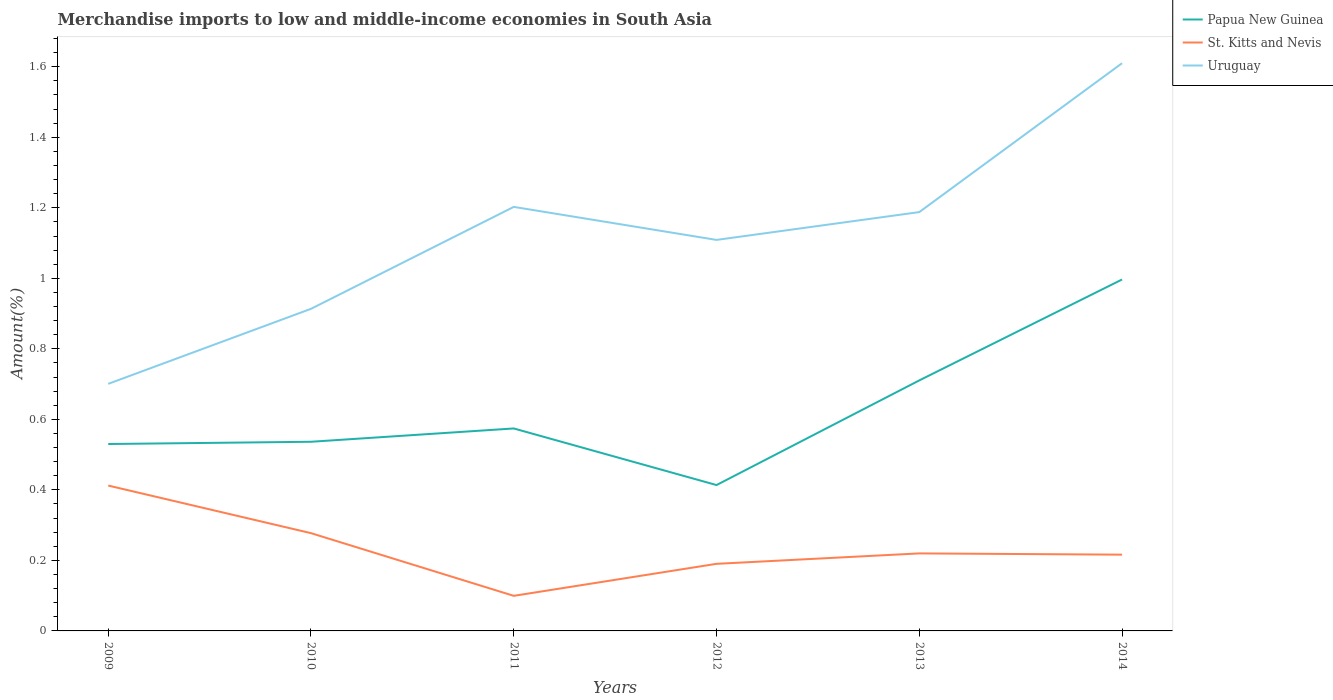Does the line corresponding to Uruguay intersect with the line corresponding to Papua New Guinea?
Offer a very short reply. No. Is the number of lines equal to the number of legend labels?
Offer a very short reply. Yes. Across all years, what is the maximum percentage of amount earned from merchandise imports in Papua New Guinea?
Offer a terse response. 0.41. What is the total percentage of amount earned from merchandise imports in Uruguay in the graph?
Offer a terse response. -0.42. What is the difference between the highest and the second highest percentage of amount earned from merchandise imports in St. Kitts and Nevis?
Your response must be concise. 0.31. How many lines are there?
Keep it short and to the point. 3. How many years are there in the graph?
Make the answer very short. 6. Does the graph contain any zero values?
Offer a very short reply. No. Does the graph contain grids?
Give a very brief answer. No. What is the title of the graph?
Give a very brief answer. Merchandise imports to low and middle-income economies in South Asia. Does "St. Martin (French part)" appear as one of the legend labels in the graph?
Ensure brevity in your answer.  No. What is the label or title of the X-axis?
Ensure brevity in your answer.  Years. What is the label or title of the Y-axis?
Your answer should be very brief. Amount(%). What is the Amount(%) in Papua New Guinea in 2009?
Make the answer very short. 0.53. What is the Amount(%) of St. Kitts and Nevis in 2009?
Provide a short and direct response. 0.41. What is the Amount(%) in Uruguay in 2009?
Offer a terse response. 0.7. What is the Amount(%) in Papua New Guinea in 2010?
Your answer should be compact. 0.54. What is the Amount(%) of St. Kitts and Nevis in 2010?
Make the answer very short. 0.28. What is the Amount(%) in Uruguay in 2010?
Your answer should be compact. 0.91. What is the Amount(%) in Papua New Guinea in 2011?
Offer a very short reply. 0.57. What is the Amount(%) of St. Kitts and Nevis in 2011?
Your response must be concise. 0.1. What is the Amount(%) of Uruguay in 2011?
Provide a short and direct response. 1.2. What is the Amount(%) of Papua New Guinea in 2012?
Provide a succinct answer. 0.41. What is the Amount(%) of St. Kitts and Nevis in 2012?
Provide a succinct answer. 0.19. What is the Amount(%) of Uruguay in 2012?
Keep it short and to the point. 1.11. What is the Amount(%) in Papua New Guinea in 2013?
Your answer should be compact. 0.71. What is the Amount(%) in St. Kitts and Nevis in 2013?
Your answer should be very brief. 0.22. What is the Amount(%) of Uruguay in 2013?
Your answer should be very brief. 1.19. What is the Amount(%) of Papua New Guinea in 2014?
Your response must be concise. 1. What is the Amount(%) in St. Kitts and Nevis in 2014?
Keep it short and to the point. 0.22. What is the Amount(%) in Uruguay in 2014?
Keep it short and to the point. 1.61. Across all years, what is the maximum Amount(%) in Papua New Guinea?
Offer a very short reply. 1. Across all years, what is the maximum Amount(%) in St. Kitts and Nevis?
Offer a very short reply. 0.41. Across all years, what is the maximum Amount(%) in Uruguay?
Offer a very short reply. 1.61. Across all years, what is the minimum Amount(%) of Papua New Guinea?
Your answer should be compact. 0.41. Across all years, what is the minimum Amount(%) of St. Kitts and Nevis?
Ensure brevity in your answer.  0.1. Across all years, what is the minimum Amount(%) in Uruguay?
Make the answer very short. 0.7. What is the total Amount(%) in Papua New Guinea in the graph?
Offer a very short reply. 3.76. What is the total Amount(%) in St. Kitts and Nevis in the graph?
Your answer should be very brief. 1.42. What is the total Amount(%) of Uruguay in the graph?
Provide a short and direct response. 6.72. What is the difference between the Amount(%) of Papua New Guinea in 2009 and that in 2010?
Provide a short and direct response. -0.01. What is the difference between the Amount(%) in St. Kitts and Nevis in 2009 and that in 2010?
Make the answer very short. 0.13. What is the difference between the Amount(%) of Uruguay in 2009 and that in 2010?
Your answer should be very brief. -0.21. What is the difference between the Amount(%) of Papua New Guinea in 2009 and that in 2011?
Your answer should be compact. -0.04. What is the difference between the Amount(%) in St. Kitts and Nevis in 2009 and that in 2011?
Ensure brevity in your answer.  0.31. What is the difference between the Amount(%) in Uruguay in 2009 and that in 2011?
Ensure brevity in your answer.  -0.5. What is the difference between the Amount(%) of Papua New Guinea in 2009 and that in 2012?
Your answer should be very brief. 0.12. What is the difference between the Amount(%) of St. Kitts and Nevis in 2009 and that in 2012?
Give a very brief answer. 0.22. What is the difference between the Amount(%) in Uruguay in 2009 and that in 2012?
Offer a very short reply. -0.41. What is the difference between the Amount(%) of Papua New Guinea in 2009 and that in 2013?
Provide a succinct answer. -0.18. What is the difference between the Amount(%) in St. Kitts and Nevis in 2009 and that in 2013?
Ensure brevity in your answer.  0.19. What is the difference between the Amount(%) of Uruguay in 2009 and that in 2013?
Make the answer very short. -0.49. What is the difference between the Amount(%) in Papua New Guinea in 2009 and that in 2014?
Keep it short and to the point. -0.47. What is the difference between the Amount(%) in St. Kitts and Nevis in 2009 and that in 2014?
Your response must be concise. 0.2. What is the difference between the Amount(%) in Uruguay in 2009 and that in 2014?
Keep it short and to the point. -0.91. What is the difference between the Amount(%) of Papua New Guinea in 2010 and that in 2011?
Offer a terse response. -0.04. What is the difference between the Amount(%) of St. Kitts and Nevis in 2010 and that in 2011?
Your answer should be compact. 0.18. What is the difference between the Amount(%) of Uruguay in 2010 and that in 2011?
Ensure brevity in your answer.  -0.29. What is the difference between the Amount(%) in Papua New Guinea in 2010 and that in 2012?
Your answer should be compact. 0.12. What is the difference between the Amount(%) of St. Kitts and Nevis in 2010 and that in 2012?
Provide a succinct answer. 0.09. What is the difference between the Amount(%) of Uruguay in 2010 and that in 2012?
Make the answer very short. -0.2. What is the difference between the Amount(%) in Papua New Guinea in 2010 and that in 2013?
Your answer should be very brief. -0.17. What is the difference between the Amount(%) of St. Kitts and Nevis in 2010 and that in 2013?
Offer a very short reply. 0.06. What is the difference between the Amount(%) in Uruguay in 2010 and that in 2013?
Give a very brief answer. -0.27. What is the difference between the Amount(%) of Papua New Guinea in 2010 and that in 2014?
Give a very brief answer. -0.46. What is the difference between the Amount(%) in St. Kitts and Nevis in 2010 and that in 2014?
Provide a short and direct response. 0.06. What is the difference between the Amount(%) of Uruguay in 2010 and that in 2014?
Offer a terse response. -0.7. What is the difference between the Amount(%) in Papua New Guinea in 2011 and that in 2012?
Offer a terse response. 0.16. What is the difference between the Amount(%) in St. Kitts and Nevis in 2011 and that in 2012?
Offer a terse response. -0.09. What is the difference between the Amount(%) of Uruguay in 2011 and that in 2012?
Ensure brevity in your answer.  0.09. What is the difference between the Amount(%) in Papua New Guinea in 2011 and that in 2013?
Ensure brevity in your answer.  -0.14. What is the difference between the Amount(%) of St. Kitts and Nevis in 2011 and that in 2013?
Your answer should be very brief. -0.12. What is the difference between the Amount(%) of Uruguay in 2011 and that in 2013?
Offer a very short reply. 0.01. What is the difference between the Amount(%) of Papua New Guinea in 2011 and that in 2014?
Keep it short and to the point. -0.42. What is the difference between the Amount(%) of St. Kitts and Nevis in 2011 and that in 2014?
Your response must be concise. -0.12. What is the difference between the Amount(%) of Uruguay in 2011 and that in 2014?
Give a very brief answer. -0.41. What is the difference between the Amount(%) in Papua New Guinea in 2012 and that in 2013?
Your answer should be compact. -0.3. What is the difference between the Amount(%) of St. Kitts and Nevis in 2012 and that in 2013?
Offer a terse response. -0.03. What is the difference between the Amount(%) in Uruguay in 2012 and that in 2013?
Provide a succinct answer. -0.08. What is the difference between the Amount(%) of Papua New Guinea in 2012 and that in 2014?
Provide a succinct answer. -0.58. What is the difference between the Amount(%) in St. Kitts and Nevis in 2012 and that in 2014?
Provide a short and direct response. -0.03. What is the difference between the Amount(%) of Uruguay in 2012 and that in 2014?
Keep it short and to the point. -0.5. What is the difference between the Amount(%) of Papua New Guinea in 2013 and that in 2014?
Offer a terse response. -0.29. What is the difference between the Amount(%) of St. Kitts and Nevis in 2013 and that in 2014?
Offer a terse response. 0. What is the difference between the Amount(%) in Uruguay in 2013 and that in 2014?
Keep it short and to the point. -0.42. What is the difference between the Amount(%) of Papua New Guinea in 2009 and the Amount(%) of St. Kitts and Nevis in 2010?
Your response must be concise. 0.25. What is the difference between the Amount(%) of Papua New Guinea in 2009 and the Amount(%) of Uruguay in 2010?
Your answer should be compact. -0.38. What is the difference between the Amount(%) of St. Kitts and Nevis in 2009 and the Amount(%) of Uruguay in 2010?
Provide a succinct answer. -0.5. What is the difference between the Amount(%) in Papua New Guinea in 2009 and the Amount(%) in St. Kitts and Nevis in 2011?
Keep it short and to the point. 0.43. What is the difference between the Amount(%) in Papua New Guinea in 2009 and the Amount(%) in Uruguay in 2011?
Offer a terse response. -0.67. What is the difference between the Amount(%) in St. Kitts and Nevis in 2009 and the Amount(%) in Uruguay in 2011?
Your response must be concise. -0.79. What is the difference between the Amount(%) of Papua New Guinea in 2009 and the Amount(%) of St. Kitts and Nevis in 2012?
Your answer should be compact. 0.34. What is the difference between the Amount(%) of Papua New Guinea in 2009 and the Amount(%) of Uruguay in 2012?
Offer a very short reply. -0.58. What is the difference between the Amount(%) in St. Kitts and Nevis in 2009 and the Amount(%) in Uruguay in 2012?
Your answer should be very brief. -0.7. What is the difference between the Amount(%) of Papua New Guinea in 2009 and the Amount(%) of St. Kitts and Nevis in 2013?
Your answer should be compact. 0.31. What is the difference between the Amount(%) in Papua New Guinea in 2009 and the Amount(%) in Uruguay in 2013?
Offer a terse response. -0.66. What is the difference between the Amount(%) in St. Kitts and Nevis in 2009 and the Amount(%) in Uruguay in 2013?
Your answer should be compact. -0.78. What is the difference between the Amount(%) in Papua New Guinea in 2009 and the Amount(%) in St. Kitts and Nevis in 2014?
Offer a very short reply. 0.31. What is the difference between the Amount(%) in Papua New Guinea in 2009 and the Amount(%) in Uruguay in 2014?
Provide a succinct answer. -1.08. What is the difference between the Amount(%) of St. Kitts and Nevis in 2009 and the Amount(%) of Uruguay in 2014?
Provide a short and direct response. -1.2. What is the difference between the Amount(%) in Papua New Guinea in 2010 and the Amount(%) in St. Kitts and Nevis in 2011?
Your answer should be very brief. 0.44. What is the difference between the Amount(%) of Papua New Guinea in 2010 and the Amount(%) of Uruguay in 2011?
Give a very brief answer. -0.67. What is the difference between the Amount(%) in St. Kitts and Nevis in 2010 and the Amount(%) in Uruguay in 2011?
Offer a very short reply. -0.93. What is the difference between the Amount(%) in Papua New Guinea in 2010 and the Amount(%) in St. Kitts and Nevis in 2012?
Give a very brief answer. 0.35. What is the difference between the Amount(%) in Papua New Guinea in 2010 and the Amount(%) in Uruguay in 2012?
Ensure brevity in your answer.  -0.57. What is the difference between the Amount(%) in St. Kitts and Nevis in 2010 and the Amount(%) in Uruguay in 2012?
Provide a succinct answer. -0.83. What is the difference between the Amount(%) of Papua New Guinea in 2010 and the Amount(%) of St. Kitts and Nevis in 2013?
Your answer should be very brief. 0.32. What is the difference between the Amount(%) of Papua New Guinea in 2010 and the Amount(%) of Uruguay in 2013?
Give a very brief answer. -0.65. What is the difference between the Amount(%) of St. Kitts and Nevis in 2010 and the Amount(%) of Uruguay in 2013?
Keep it short and to the point. -0.91. What is the difference between the Amount(%) in Papua New Guinea in 2010 and the Amount(%) in St. Kitts and Nevis in 2014?
Provide a succinct answer. 0.32. What is the difference between the Amount(%) in Papua New Guinea in 2010 and the Amount(%) in Uruguay in 2014?
Offer a terse response. -1.07. What is the difference between the Amount(%) of St. Kitts and Nevis in 2010 and the Amount(%) of Uruguay in 2014?
Ensure brevity in your answer.  -1.33. What is the difference between the Amount(%) of Papua New Guinea in 2011 and the Amount(%) of St. Kitts and Nevis in 2012?
Keep it short and to the point. 0.38. What is the difference between the Amount(%) in Papua New Guinea in 2011 and the Amount(%) in Uruguay in 2012?
Provide a succinct answer. -0.53. What is the difference between the Amount(%) in St. Kitts and Nevis in 2011 and the Amount(%) in Uruguay in 2012?
Provide a short and direct response. -1.01. What is the difference between the Amount(%) of Papua New Guinea in 2011 and the Amount(%) of St. Kitts and Nevis in 2013?
Keep it short and to the point. 0.35. What is the difference between the Amount(%) in Papua New Guinea in 2011 and the Amount(%) in Uruguay in 2013?
Ensure brevity in your answer.  -0.61. What is the difference between the Amount(%) of St. Kitts and Nevis in 2011 and the Amount(%) of Uruguay in 2013?
Offer a very short reply. -1.09. What is the difference between the Amount(%) in Papua New Guinea in 2011 and the Amount(%) in St. Kitts and Nevis in 2014?
Give a very brief answer. 0.36. What is the difference between the Amount(%) of Papua New Guinea in 2011 and the Amount(%) of Uruguay in 2014?
Keep it short and to the point. -1.04. What is the difference between the Amount(%) of St. Kitts and Nevis in 2011 and the Amount(%) of Uruguay in 2014?
Offer a terse response. -1.51. What is the difference between the Amount(%) of Papua New Guinea in 2012 and the Amount(%) of St. Kitts and Nevis in 2013?
Provide a short and direct response. 0.19. What is the difference between the Amount(%) in Papua New Guinea in 2012 and the Amount(%) in Uruguay in 2013?
Ensure brevity in your answer.  -0.77. What is the difference between the Amount(%) of St. Kitts and Nevis in 2012 and the Amount(%) of Uruguay in 2013?
Your answer should be very brief. -1. What is the difference between the Amount(%) of Papua New Guinea in 2012 and the Amount(%) of St. Kitts and Nevis in 2014?
Your answer should be compact. 0.2. What is the difference between the Amount(%) in Papua New Guinea in 2012 and the Amount(%) in Uruguay in 2014?
Provide a short and direct response. -1.2. What is the difference between the Amount(%) in St. Kitts and Nevis in 2012 and the Amount(%) in Uruguay in 2014?
Make the answer very short. -1.42. What is the difference between the Amount(%) of Papua New Guinea in 2013 and the Amount(%) of St. Kitts and Nevis in 2014?
Ensure brevity in your answer.  0.49. What is the difference between the Amount(%) in Papua New Guinea in 2013 and the Amount(%) in Uruguay in 2014?
Make the answer very short. -0.9. What is the difference between the Amount(%) in St. Kitts and Nevis in 2013 and the Amount(%) in Uruguay in 2014?
Your response must be concise. -1.39. What is the average Amount(%) of Papua New Guinea per year?
Offer a terse response. 0.63. What is the average Amount(%) in St. Kitts and Nevis per year?
Your response must be concise. 0.24. What is the average Amount(%) in Uruguay per year?
Your answer should be very brief. 1.12. In the year 2009, what is the difference between the Amount(%) in Papua New Guinea and Amount(%) in St. Kitts and Nevis?
Provide a short and direct response. 0.12. In the year 2009, what is the difference between the Amount(%) of Papua New Guinea and Amount(%) of Uruguay?
Provide a short and direct response. -0.17. In the year 2009, what is the difference between the Amount(%) of St. Kitts and Nevis and Amount(%) of Uruguay?
Give a very brief answer. -0.29. In the year 2010, what is the difference between the Amount(%) in Papua New Guinea and Amount(%) in St. Kitts and Nevis?
Keep it short and to the point. 0.26. In the year 2010, what is the difference between the Amount(%) in Papua New Guinea and Amount(%) in Uruguay?
Provide a short and direct response. -0.38. In the year 2010, what is the difference between the Amount(%) in St. Kitts and Nevis and Amount(%) in Uruguay?
Provide a succinct answer. -0.64. In the year 2011, what is the difference between the Amount(%) of Papua New Guinea and Amount(%) of St. Kitts and Nevis?
Make the answer very short. 0.47. In the year 2011, what is the difference between the Amount(%) in Papua New Guinea and Amount(%) in Uruguay?
Ensure brevity in your answer.  -0.63. In the year 2011, what is the difference between the Amount(%) of St. Kitts and Nevis and Amount(%) of Uruguay?
Offer a terse response. -1.1. In the year 2012, what is the difference between the Amount(%) of Papua New Guinea and Amount(%) of St. Kitts and Nevis?
Provide a short and direct response. 0.22. In the year 2012, what is the difference between the Amount(%) in Papua New Guinea and Amount(%) in Uruguay?
Provide a short and direct response. -0.7. In the year 2012, what is the difference between the Amount(%) in St. Kitts and Nevis and Amount(%) in Uruguay?
Make the answer very short. -0.92. In the year 2013, what is the difference between the Amount(%) of Papua New Guinea and Amount(%) of St. Kitts and Nevis?
Your answer should be very brief. 0.49. In the year 2013, what is the difference between the Amount(%) of Papua New Guinea and Amount(%) of Uruguay?
Offer a very short reply. -0.48. In the year 2013, what is the difference between the Amount(%) of St. Kitts and Nevis and Amount(%) of Uruguay?
Your answer should be compact. -0.97. In the year 2014, what is the difference between the Amount(%) in Papua New Guinea and Amount(%) in St. Kitts and Nevis?
Provide a short and direct response. 0.78. In the year 2014, what is the difference between the Amount(%) of Papua New Guinea and Amount(%) of Uruguay?
Offer a very short reply. -0.61. In the year 2014, what is the difference between the Amount(%) in St. Kitts and Nevis and Amount(%) in Uruguay?
Provide a succinct answer. -1.39. What is the ratio of the Amount(%) of St. Kitts and Nevis in 2009 to that in 2010?
Keep it short and to the point. 1.49. What is the ratio of the Amount(%) of Uruguay in 2009 to that in 2010?
Offer a very short reply. 0.77. What is the ratio of the Amount(%) in Papua New Guinea in 2009 to that in 2011?
Offer a very short reply. 0.92. What is the ratio of the Amount(%) in St. Kitts and Nevis in 2009 to that in 2011?
Ensure brevity in your answer.  4.14. What is the ratio of the Amount(%) of Uruguay in 2009 to that in 2011?
Keep it short and to the point. 0.58. What is the ratio of the Amount(%) of Papua New Guinea in 2009 to that in 2012?
Offer a very short reply. 1.28. What is the ratio of the Amount(%) of St. Kitts and Nevis in 2009 to that in 2012?
Make the answer very short. 2.17. What is the ratio of the Amount(%) of Uruguay in 2009 to that in 2012?
Offer a terse response. 0.63. What is the ratio of the Amount(%) of Papua New Guinea in 2009 to that in 2013?
Give a very brief answer. 0.75. What is the ratio of the Amount(%) in St. Kitts and Nevis in 2009 to that in 2013?
Your answer should be compact. 1.87. What is the ratio of the Amount(%) in Uruguay in 2009 to that in 2013?
Ensure brevity in your answer.  0.59. What is the ratio of the Amount(%) in Papua New Guinea in 2009 to that in 2014?
Ensure brevity in your answer.  0.53. What is the ratio of the Amount(%) in St. Kitts and Nevis in 2009 to that in 2014?
Keep it short and to the point. 1.91. What is the ratio of the Amount(%) of Uruguay in 2009 to that in 2014?
Offer a very short reply. 0.44. What is the ratio of the Amount(%) of Papua New Guinea in 2010 to that in 2011?
Give a very brief answer. 0.93. What is the ratio of the Amount(%) of St. Kitts and Nevis in 2010 to that in 2011?
Ensure brevity in your answer.  2.79. What is the ratio of the Amount(%) of Uruguay in 2010 to that in 2011?
Your response must be concise. 0.76. What is the ratio of the Amount(%) of Papua New Guinea in 2010 to that in 2012?
Make the answer very short. 1.3. What is the ratio of the Amount(%) of St. Kitts and Nevis in 2010 to that in 2012?
Keep it short and to the point. 1.46. What is the ratio of the Amount(%) in Uruguay in 2010 to that in 2012?
Provide a short and direct response. 0.82. What is the ratio of the Amount(%) of Papua New Guinea in 2010 to that in 2013?
Offer a terse response. 0.76. What is the ratio of the Amount(%) in St. Kitts and Nevis in 2010 to that in 2013?
Provide a succinct answer. 1.26. What is the ratio of the Amount(%) of Uruguay in 2010 to that in 2013?
Your response must be concise. 0.77. What is the ratio of the Amount(%) in Papua New Guinea in 2010 to that in 2014?
Offer a very short reply. 0.54. What is the ratio of the Amount(%) of St. Kitts and Nevis in 2010 to that in 2014?
Provide a succinct answer. 1.28. What is the ratio of the Amount(%) in Uruguay in 2010 to that in 2014?
Your answer should be very brief. 0.57. What is the ratio of the Amount(%) in Papua New Guinea in 2011 to that in 2012?
Provide a short and direct response. 1.39. What is the ratio of the Amount(%) in St. Kitts and Nevis in 2011 to that in 2012?
Offer a very short reply. 0.52. What is the ratio of the Amount(%) of Uruguay in 2011 to that in 2012?
Provide a short and direct response. 1.08. What is the ratio of the Amount(%) of Papua New Guinea in 2011 to that in 2013?
Your answer should be compact. 0.81. What is the ratio of the Amount(%) in St. Kitts and Nevis in 2011 to that in 2013?
Ensure brevity in your answer.  0.45. What is the ratio of the Amount(%) in Uruguay in 2011 to that in 2013?
Ensure brevity in your answer.  1.01. What is the ratio of the Amount(%) of Papua New Guinea in 2011 to that in 2014?
Offer a very short reply. 0.58. What is the ratio of the Amount(%) in St. Kitts and Nevis in 2011 to that in 2014?
Give a very brief answer. 0.46. What is the ratio of the Amount(%) of Uruguay in 2011 to that in 2014?
Offer a very short reply. 0.75. What is the ratio of the Amount(%) of Papua New Guinea in 2012 to that in 2013?
Ensure brevity in your answer.  0.58. What is the ratio of the Amount(%) of St. Kitts and Nevis in 2012 to that in 2013?
Offer a terse response. 0.87. What is the ratio of the Amount(%) in Uruguay in 2012 to that in 2013?
Provide a succinct answer. 0.93. What is the ratio of the Amount(%) in Papua New Guinea in 2012 to that in 2014?
Offer a very short reply. 0.42. What is the ratio of the Amount(%) of St. Kitts and Nevis in 2012 to that in 2014?
Ensure brevity in your answer.  0.88. What is the ratio of the Amount(%) of Uruguay in 2012 to that in 2014?
Keep it short and to the point. 0.69. What is the ratio of the Amount(%) in Papua New Guinea in 2013 to that in 2014?
Provide a succinct answer. 0.71. What is the ratio of the Amount(%) in St. Kitts and Nevis in 2013 to that in 2014?
Your response must be concise. 1.02. What is the ratio of the Amount(%) in Uruguay in 2013 to that in 2014?
Your answer should be very brief. 0.74. What is the difference between the highest and the second highest Amount(%) in Papua New Guinea?
Give a very brief answer. 0.29. What is the difference between the highest and the second highest Amount(%) in St. Kitts and Nevis?
Provide a short and direct response. 0.13. What is the difference between the highest and the second highest Amount(%) in Uruguay?
Keep it short and to the point. 0.41. What is the difference between the highest and the lowest Amount(%) of Papua New Guinea?
Your answer should be very brief. 0.58. What is the difference between the highest and the lowest Amount(%) of St. Kitts and Nevis?
Your answer should be compact. 0.31. What is the difference between the highest and the lowest Amount(%) of Uruguay?
Your answer should be very brief. 0.91. 